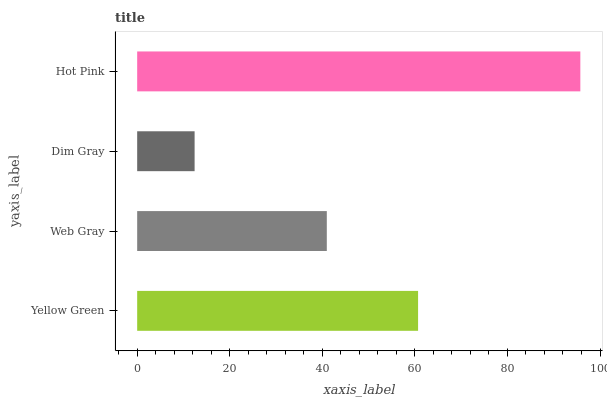Is Dim Gray the minimum?
Answer yes or no. Yes. Is Hot Pink the maximum?
Answer yes or no. Yes. Is Web Gray the minimum?
Answer yes or no. No. Is Web Gray the maximum?
Answer yes or no. No. Is Yellow Green greater than Web Gray?
Answer yes or no. Yes. Is Web Gray less than Yellow Green?
Answer yes or no. Yes. Is Web Gray greater than Yellow Green?
Answer yes or no. No. Is Yellow Green less than Web Gray?
Answer yes or no. No. Is Yellow Green the high median?
Answer yes or no. Yes. Is Web Gray the low median?
Answer yes or no. Yes. Is Web Gray the high median?
Answer yes or no. No. Is Yellow Green the low median?
Answer yes or no. No. 